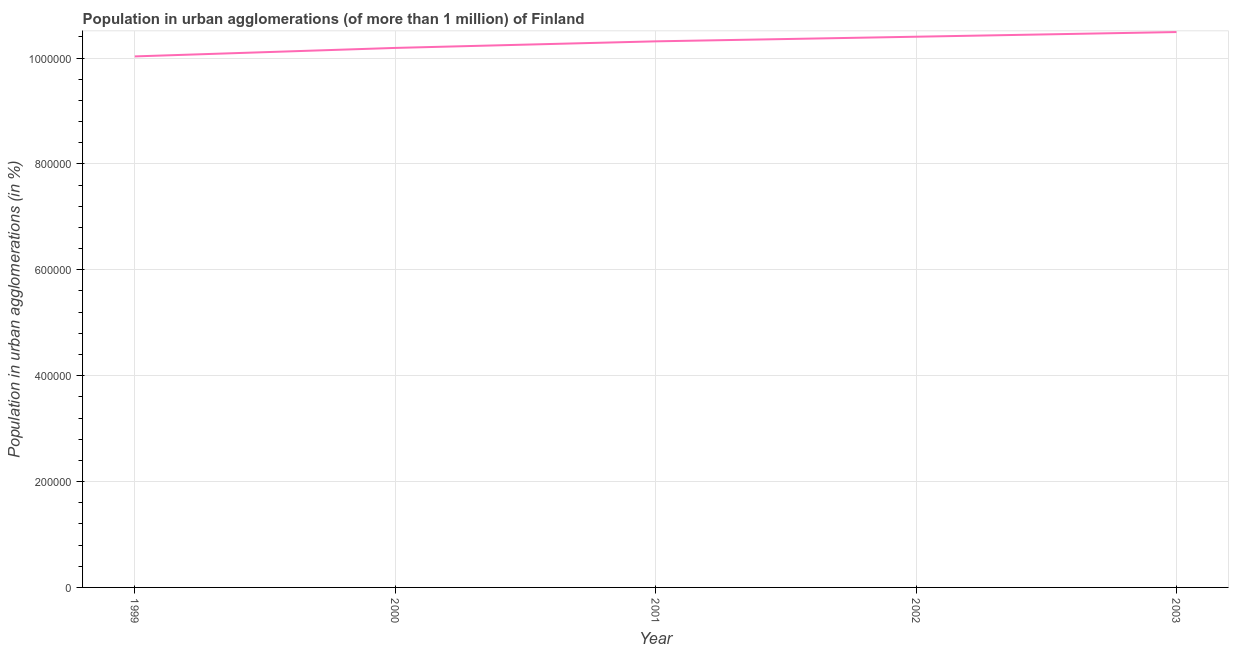What is the population in urban agglomerations in 2001?
Your answer should be very brief. 1.03e+06. Across all years, what is the maximum population in urban agglomerations?
Your answer should be very brief. 1.05e+06. Across all years, what is the minimum population in urban agglomerations?
Make the answer very short. 1.00e+06. In which year was the population in urban agglomerations minimum?
Provide a succinct answer. 1999. What is the sum of the population in urban agglomerations?
Offer a very short reply. 5.14e+06. What is the difference between the population in urban agglomerations in 2000 and 2003?
Keep it short and to the point. -3.00e+04. What is the average population in urban agglomerations per year?
Provide a succinct answer. 1.03e+06. What is the median population in urban agglomerations?
Offer a very short reply. 1.03e+06. In how many years, is the population in urban agglomerations greater than 240000 %?
Provide a short and direct response. 5. Do a majority of the years between 2000 and 2002 (inclusive) have population in urban agglomerations greater than 120000 %?
Your answer should be very brief. Yes. What is the ratio of the population in urban agglomerations in 1999 to that in 2000?
Offer a terse response. 0.98. Is the population in urban agglomerations in 1999 less than that in 2000?
Your answer should be compact. Yes. What is the difference between the highest and the second highest population in urban agglomerations?
Make the answer very short. 8821. Is the sum of the population in urban agglomerations in 2001 and 2003 greater than the maximum population in urban agglomerations across all years?
Your answer should be very brief. Yes. What is the difference between the highest and the lowest population in urban agglomerations?
Give a very brief answer. 4.60e+04. Does the population in urban agglomerations monotonically increase over the years?
Provide a short and direct response. Yes. How many lines are there?
Offer a very short reply. 1. What is the difference between two consecutive major ticks on the Y-axis?
Your answer should be very brief. 2.00e+05. Are the values on the major ticks of Y-axis written in scientific E-notation?
Your answer should be very brief. No. Does the graph contain grids?
Make the answer very short. Yes. What is the title of the graph?
Your answer should be very brief. Population in urban agglomerations (of more than 1 million) of Finland. What is the label or title of the X-axis?
Keep it short and to the point. Year. What is the label or title of the Y-axis?
Keep it short and to the point. Population in urban agglomerations (in %). What is the Population in urban agglomerations (in %) in 1999?
Your answer should be very brief. 1.00e+06. What is the Population in urban agglomerations (in %) of 2000?
Your answer should be very brief. 1.02e+06. What is the Population in urban agglomerations (in %) in 2001?
Provide a short and direct response. 1.03e+06. What is the Population in urban agglomerations (in %) of 2002?
Provide a succinct answer. 1.04e+06. What is the Population in urban agglomerations (in %) of 2003?
Your answer should be compact. 1.05e+06. What is the difference between the Population in urban agglomerations (in %) in 1999 and 2000?
Offer a very short reply. -1.60e+04. What is the difference between the Population in urban agglomerations (in %) in 1999 and 2001?
Make the answer very short. -2.85e+04. What is the difference between the Population in urban agglomerations (in %) in 1999 and 2002?
Offer a very short reply. -3.72e+04. What is the difference between the Population in urban agglomerations (in %) in 1999 and 2003?
Your answer should be compact. -4.60e+04. What is the difference between the Population in urban agglomerations (in %) in 2000 and 2001?
Provide a short and direct response. -1.24e+04. What is the difference between the Population in urban agglomerations (in %) in 2000 and 2002?
Your response must be concise. -2.12e+04. What is the difference between the Population in urban agglomerations (in %) in 2000 and 2003?
Your answer should be compact. -3.00e+04. What is the difference between the Population in urban agglomerations (in %) in 2001 and 2002?
Make the answer very short. -8746. What is the difference between the Population in urban agglomerations (in %) in 2001 and 2003?
Provide a short and direct response. -1.76e+04. What is the difference between the Population in urban agglomerations (in %) in 2002 and 2003?
Provide a short and direct response. -8821. What is the ratio of the Population in urban agglomerations (in %) in 1999 to that in 2001?
Make the answer very short. 0.97. What is the ratio of the Population in urban agglomerations (in %) in 1999 to that in 2002?
Keep it short and to the point. 0.96. What is the ratio of the Population in urban agglomerations (in %) in 1999 to that in 2003?
Offer a very short reply. 0.96. What is the ratio of the Population in urban agglomerations (in %) in 2000 to that in 2001?
Ensure brevity in your answer.  0.99. What is the ratio of the Population in urban agglomerations (in %) in 2000 to that in 2002?
Your answer should be very brief. 0.98. What is the ratio of the Population in urban agglomerations (in %) in 2001 to that in 2002?
Offer a very short reply. 0.99. What is the ratio of the Population in urban agglomerations (in %) in 2002 to that in 2003?
Provide a short and direct response. 0.99. 